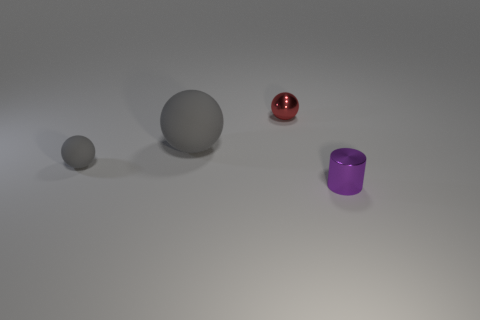Subtract all small rubber balls. How many balls are left? 2 Subtract all cyan cylinders. How many gray balls are left? 2 Subtract 1 spheres. How many spheres are left? 2 Add 2 small metallic cylinders. How many objects exist? 6 Subtract all balls. How many objects are left? 1 Add 1 matte balls. How many matte balls are left? 3 Add 3 small green rubber spheres. How many small green rubber spheres exist? 3 Subtract 0 green cubes. How many objects are left? 4 Subtract all cyan balls. Subtract all cyan cylinders. How many balls are left? 3 Subtract all big gray matte spheres. Subtract all tiny rubber balls. How many objects are left? 2 